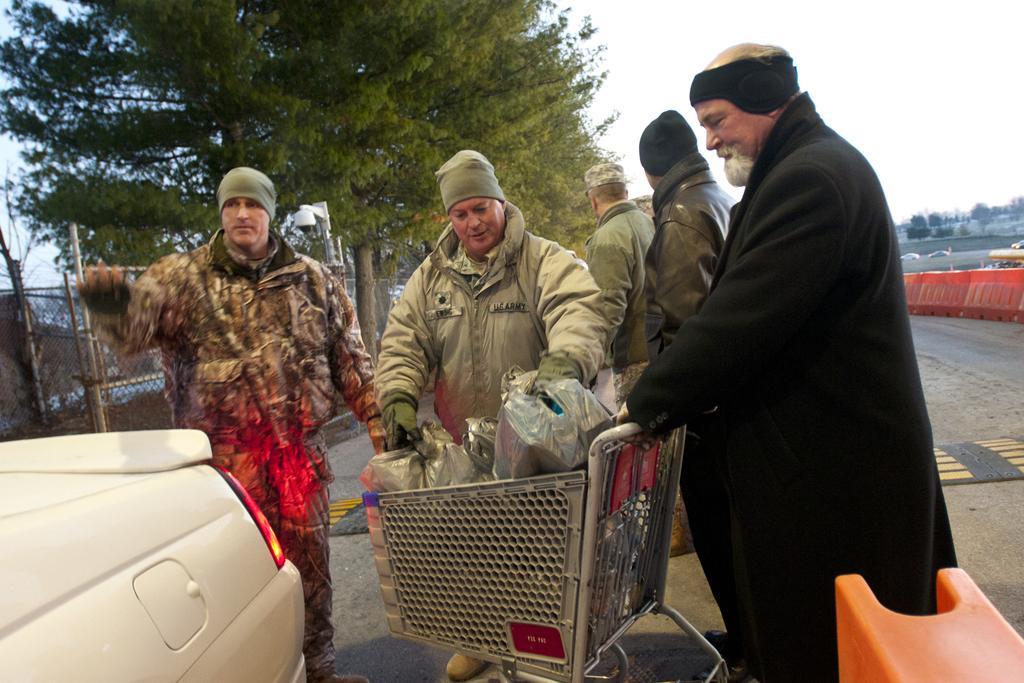Describe this image in one or two sentences. In this picture, we see the people are standing. In front of them, we see a shopping trolley containing the plastic bags. On the left side, we see a white car. In the right bottom, we see an orange color object. On the right side, we see the traffic stoppers. Behind that, we see the cars are moving on the road. On the left side, we see the fence, streetlights and the trees. On the right side, we see the trees. At the top, we see the sky. 